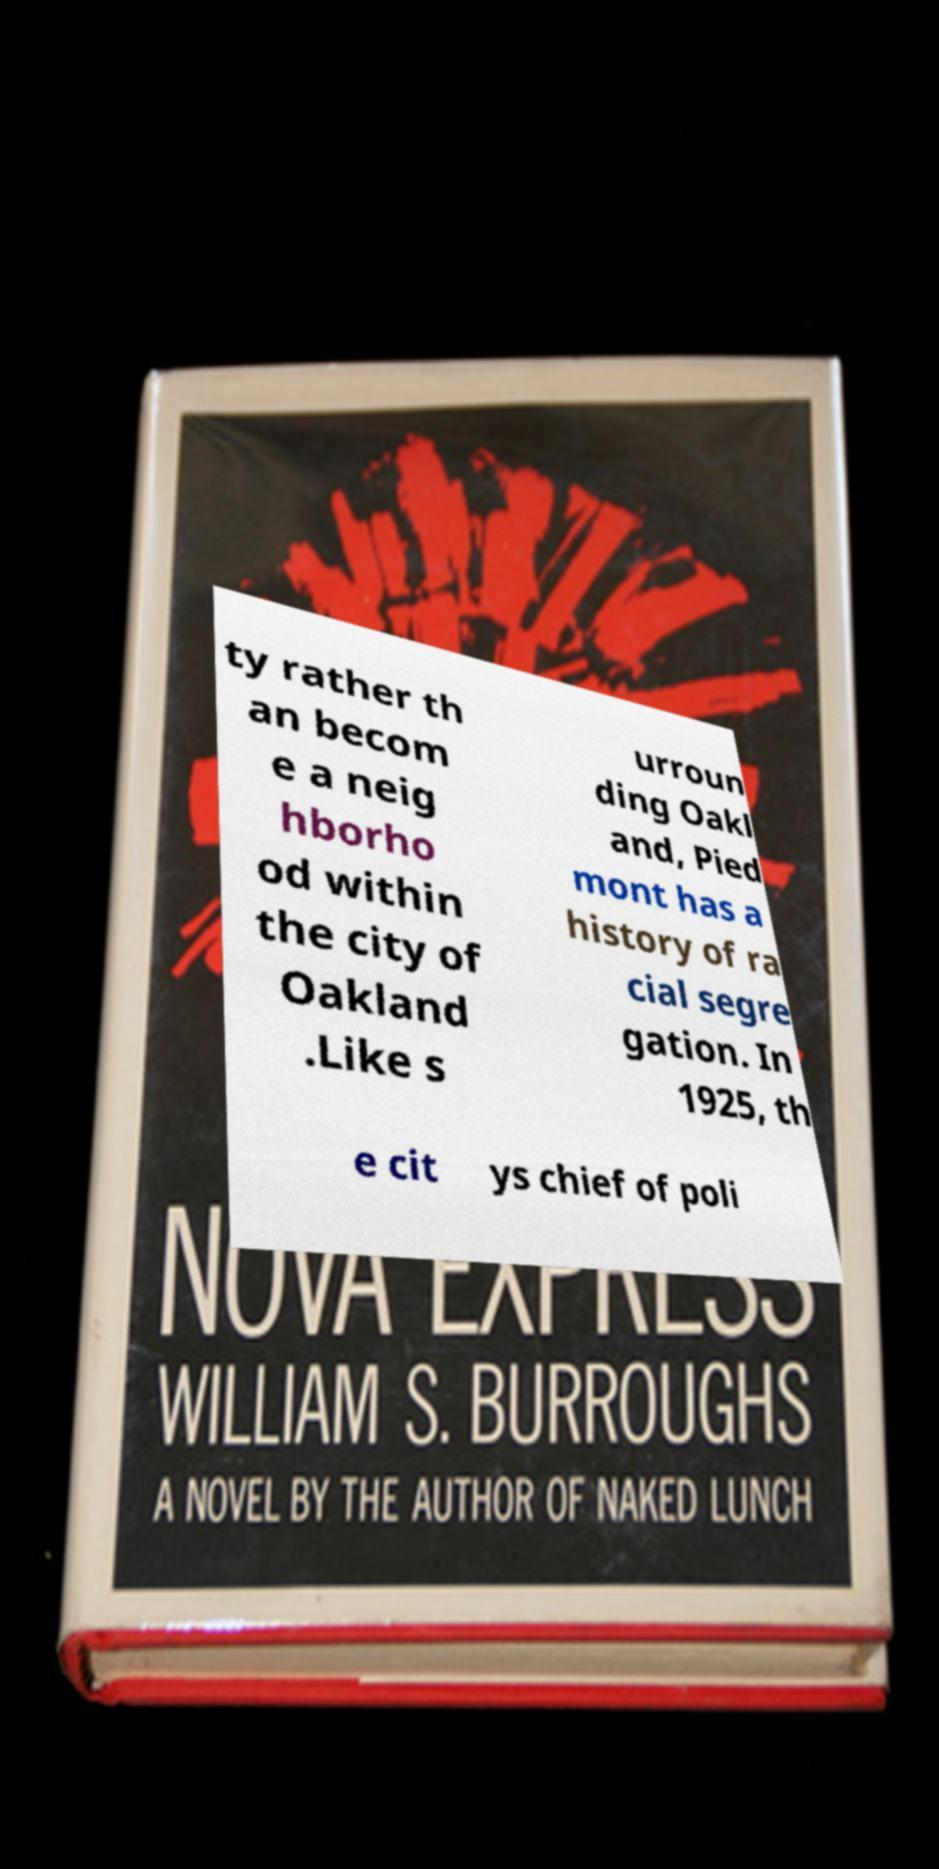Can you accurately transcribe the text from the provided image for me? ty rather th an becom e a neig hborho od within the city of Oakland .Like s urroun ding Oakl and, Pied mont has a history of ra cial segre gation. In 1925, th e cit ys chief of poli 